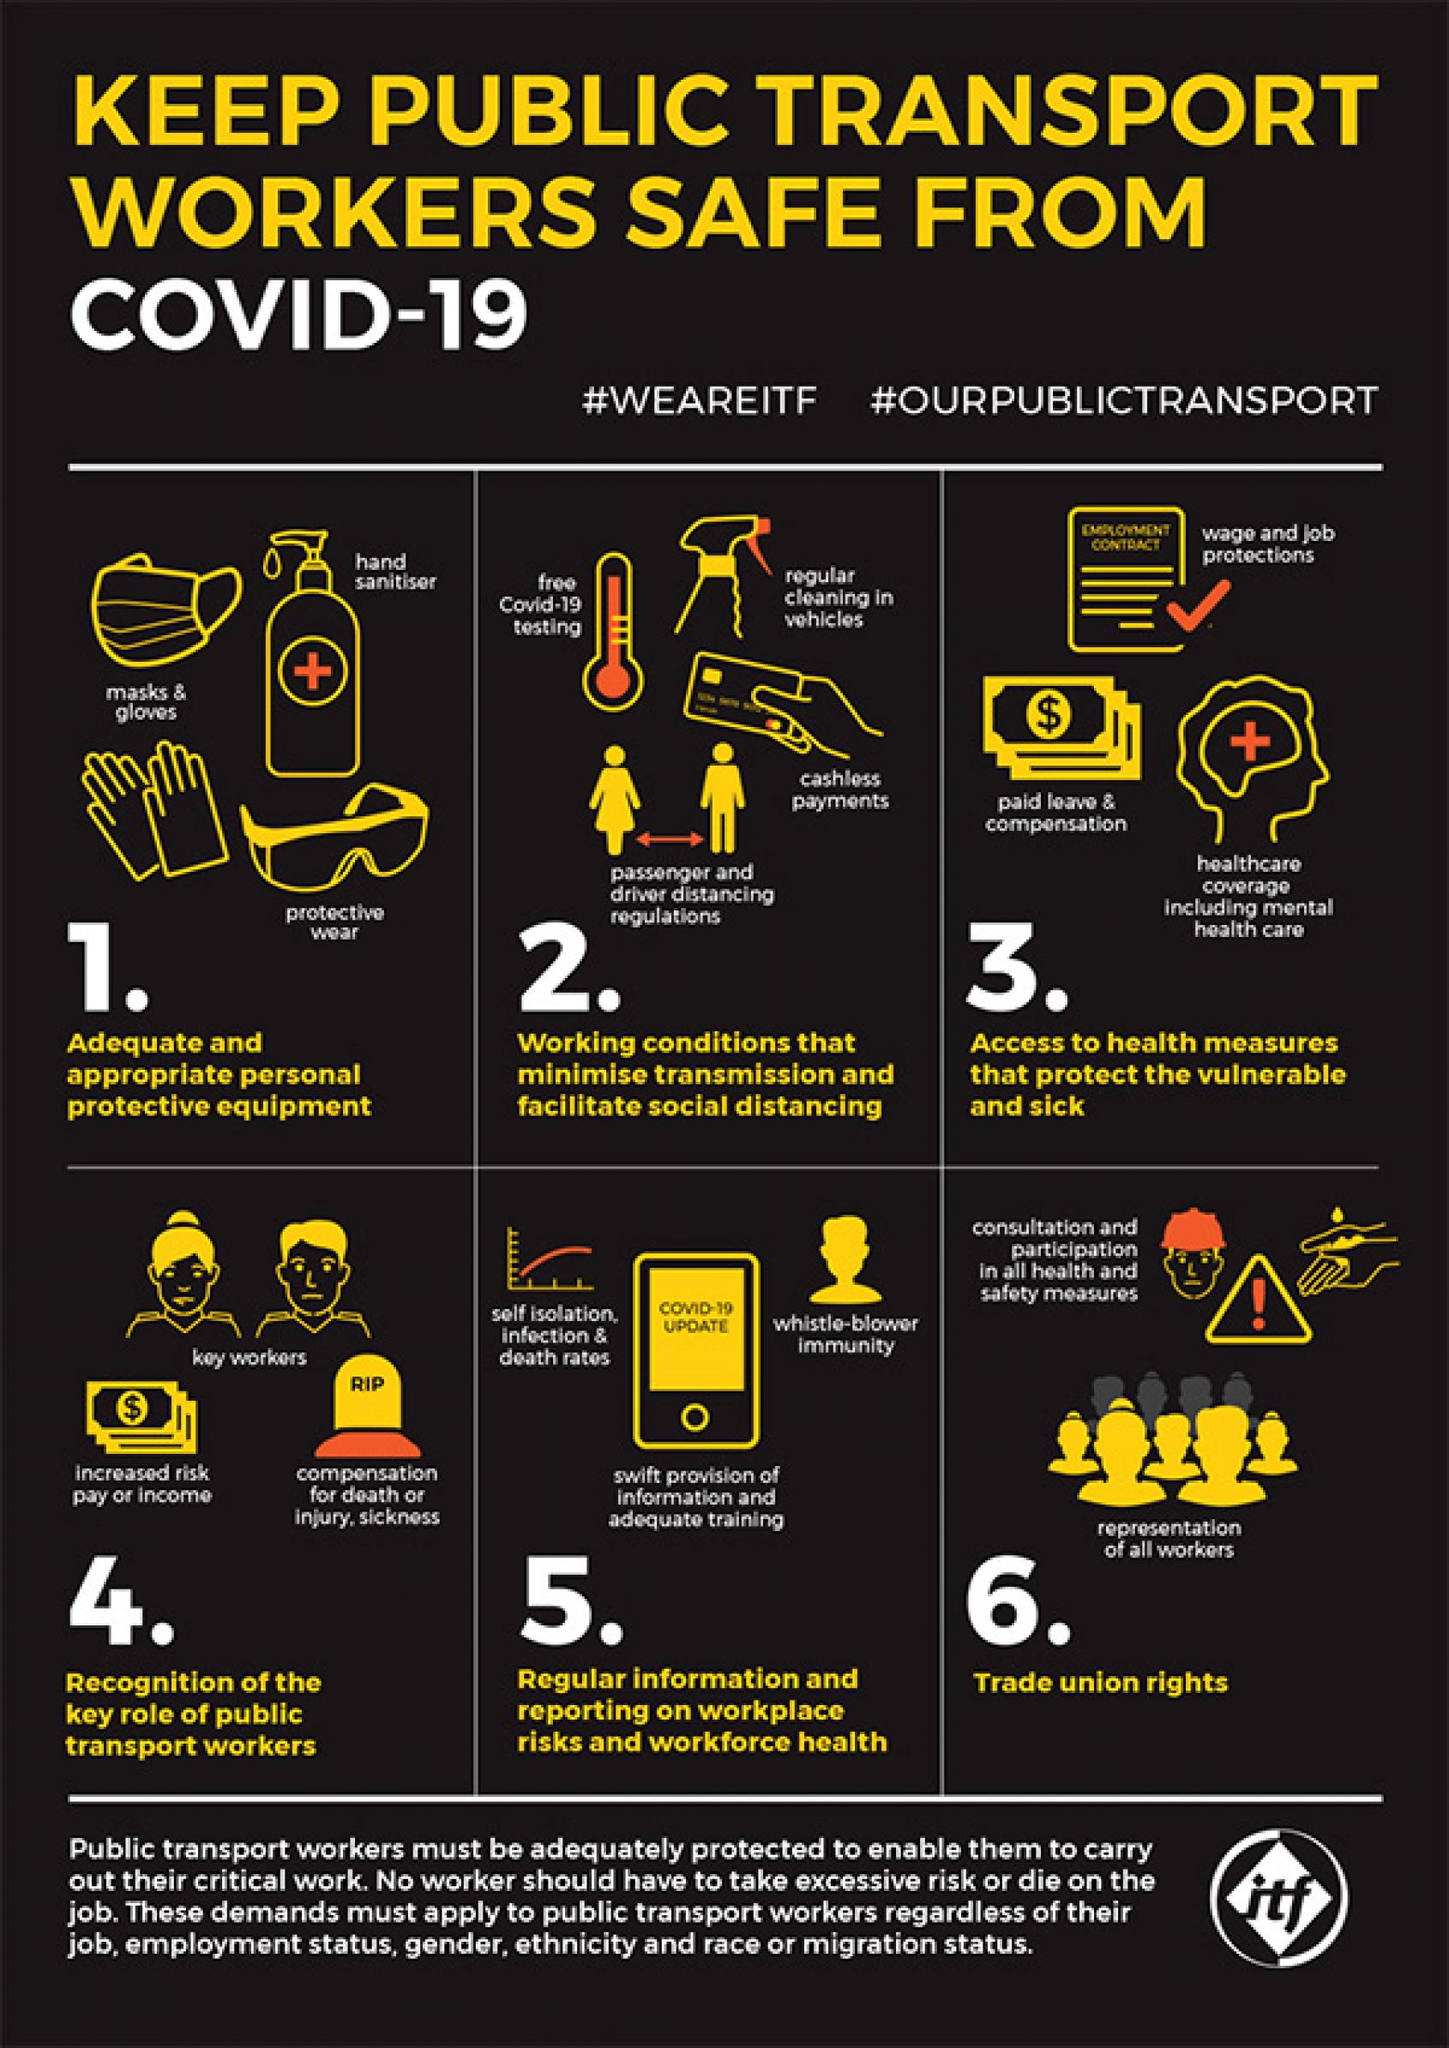List a handful of essential elements in this visual. The smart phone's screen displays information regarding COVID-19. The inscription on the headstone reads 'RIP'. The PPE shown in point 1 are masks and gloves, hand sanitizer, and protective wear. All workers deserve to have trade union rights, which is their representation in the workplace. The hashtags #WEAREITF and #OURPUBLICTRANSPORT represent a declaration of support for the transportation industry and the public's right to access it. 